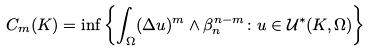<formula> <loc_0><loc_0><loc_500><loc_500>C _ { m } ( K ) = \inf \left \{ \int _ { \Omega } ( \Delta u ) ^ { m } \wedge \beta _ { n } ^ { n - m } \colon u \in \mathcal { U } ^ { * } ( K , \Omega ) \right \}</formula> 